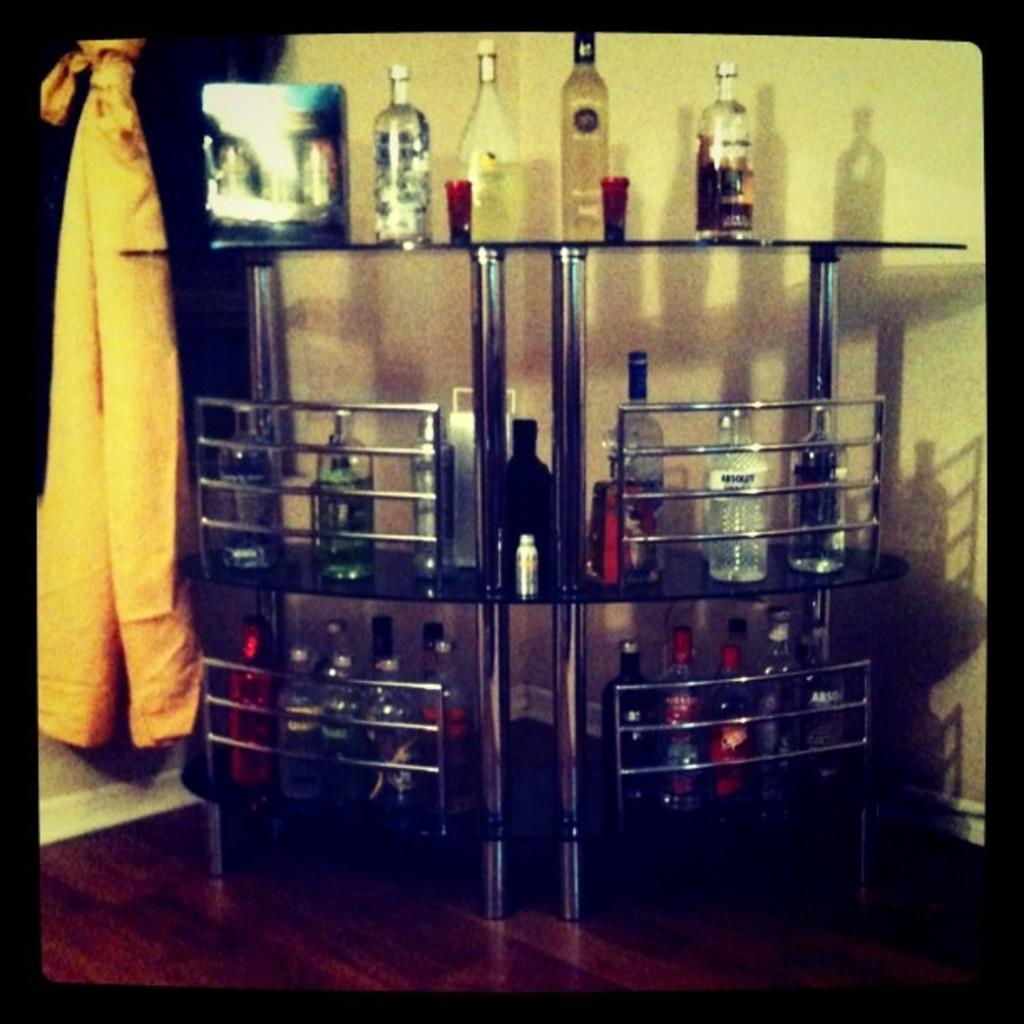What type of beverage containers are present in the image? There are wine bottles in the image. How are the wine bottles arranged in the image? The wine bottles are placed in racks. What color is the cloth on the left side of the image? The cloth on the left side of the image is yellow. What can be seen in the background of the image? There is a wall in the background of the image. What type of vessel is being used to hold the cabbage in the image? There is no cabbage or vessel present in the image. 